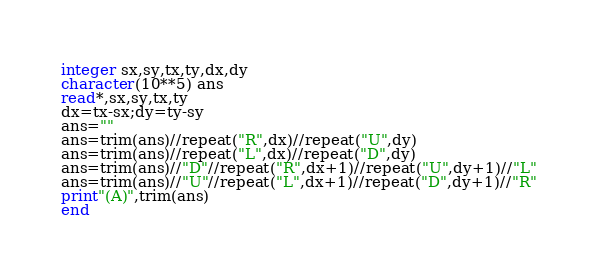<code> <loc_0><loc_0><loc_500><loc_500><_FORTRAN_>integer sx,sy,tx,ty,dx,dy
character(10**5) ans
read*,sx,sy,tx,ty
dx=tx-sx;dy=ty-sy
ans=""
ans=trim(ans)//repeat("R",dx)//repeat("U",dy)
ans=trim(ans)//repeat("L",dx)//repeat("D",dy)
ans=trim(ans)//"D"//repeat("R",dx+1)//repeat("U",dy+1)//"L"
ans=trim(ans)//"U"//repeat("L",dx+1)//repeat("D",dy+1)//"R"
print"(A)",trim(ans)
end</code> 